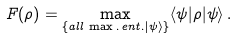Convert formula to latex. <formula><loc_0><loc_0><loc_500><loc_500>F ( \rho ) = \max _ { \{ a l l \, \max . \, e n t . | \psi \rangle \} } \langle \psi | \rho | \psi \rangle \, .</formula> 